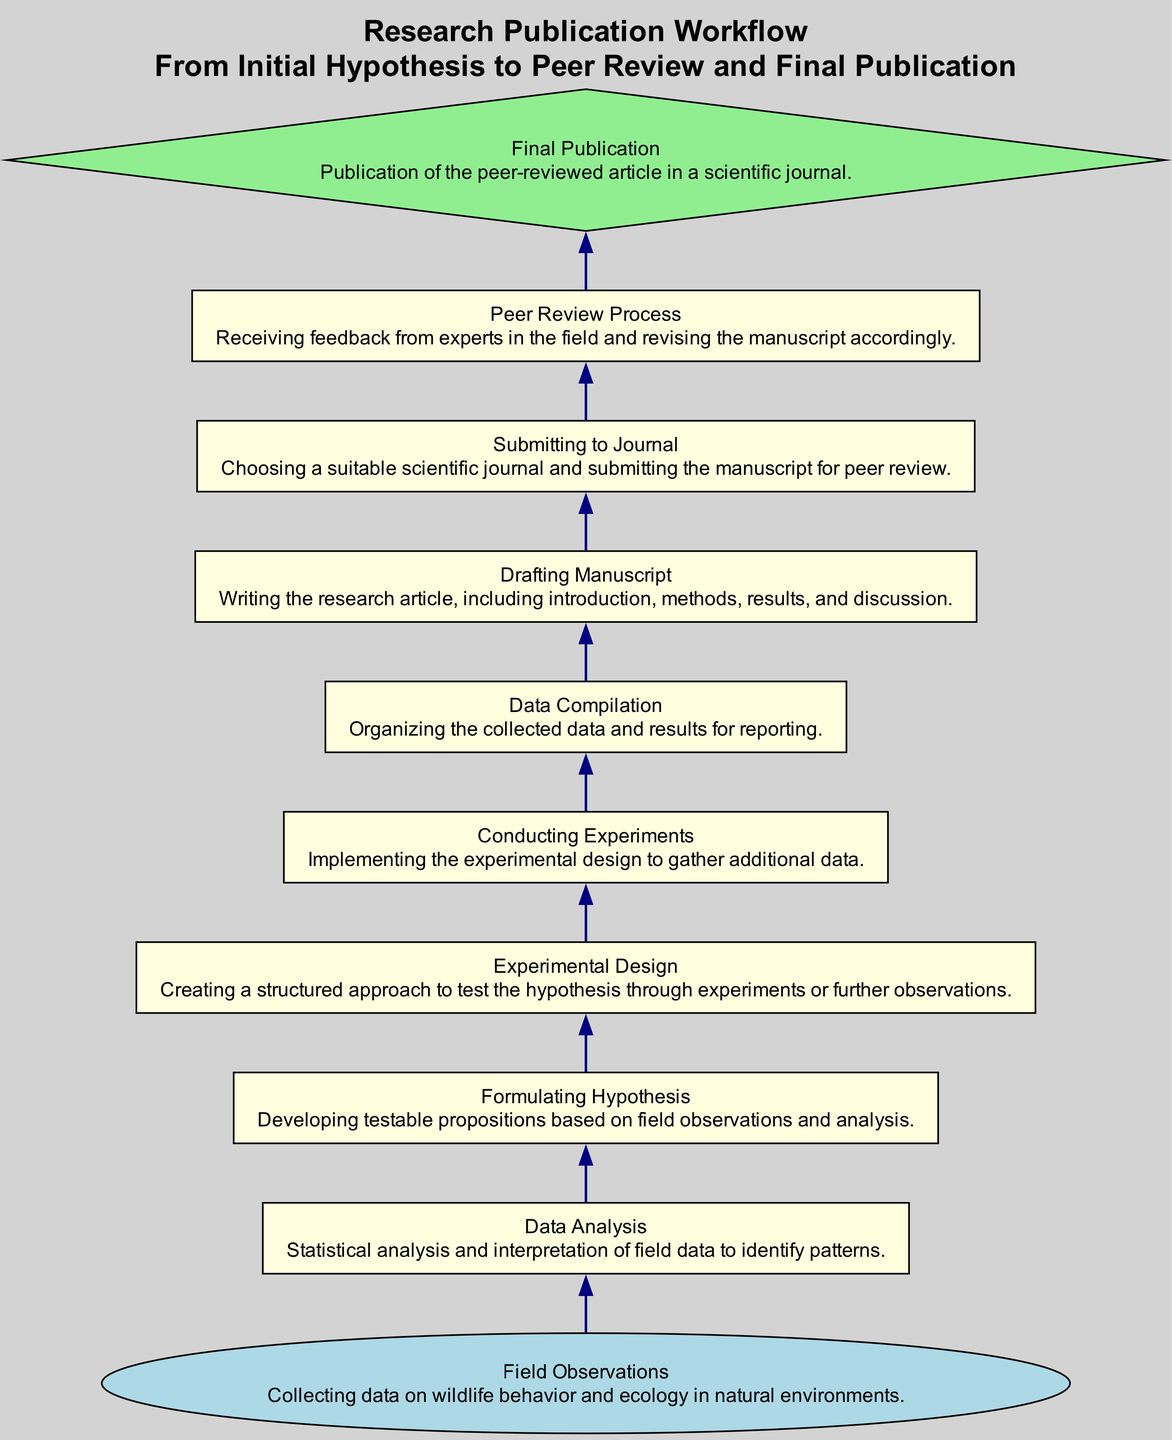What is the first step in the workflow? The first step in the workflow is Field Observations, which involves collecting data on wildlife behavior and ecology.
Answer: Field Observations How many nodes are there in the diagram? The diagram contains ten nodes representing different stages of the research publication workflow.
Answer: Ten What stage comes after Data Analysis? After Data Analysis, the next stage is Formulating Hypothesis, where testable propositions are developed based on field observations and analysis.
Answer: Formulating Hypothesis Which node is emphasized as the final result of the workflow? The final result of the workflow is emphasized with a diamond shape, labeled Final Publication, which indicates the publication of the article in a scientific journal.
Answer: Final Publication What is the relationship between Conducting Experiments and Data Compilation? Conducting Experiments leads to Data Compilation, where the organized results of the experiments are prepared for reporting.
Answer: Conducting Experiments → Data Compilation What is the role of the Peer Review Process in the workflow? The Peer Review Process involves receiving feedback from experts in the field, which is crucial for revising the manuscript before final publication.
Answer: Feedback from experts How many steps precede Final Publication? There are nine steps that precede Final Publication, starting from Field Observations and ending with the peer review process.
Answer: Nine What is the function of Drafting Manuscript in the workflow? Drafting Manuscript serves to compile the findings into a structured research article, detailing the introduction, methods, results, and discussion.
Answer: Writing the research article What is the purpose of Experimental Design? Experimental Design is critical for structuring the approach to test the hypotheses, ensuring that experiments yield valid and reliable data.
Answer: Structuring approach to test hypotheses What is the shape of the first node in the diagram? The first node, which represents Field Observations, is shaped like an oval, distinguishing it as the initial step in the workflow.
Answer: Oval 